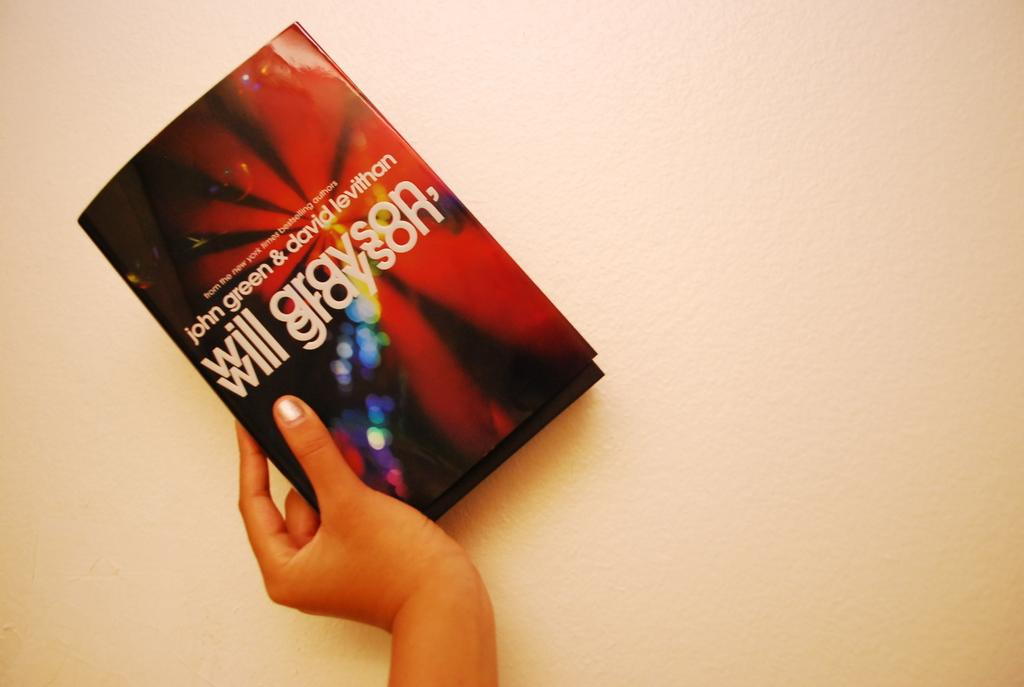Provide a one-sentence caption for the provided image. A hand holds a book called Will Grayson by Green and Levithan which has a colourful cover. 